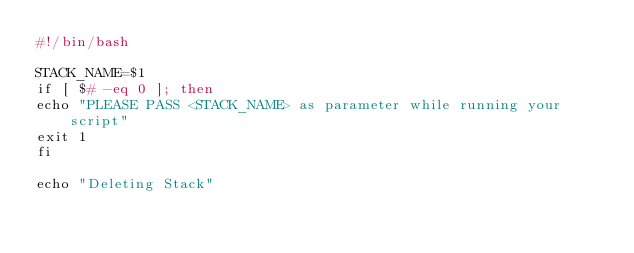Convert code to text. <code><loc_0><loc_0><loc_500><loc_500><_Bash_>#!/bin/bash

STACK_NAME=$1
if [ $# -eq 0 ]; then
echo "PLEASE PASS <STACK_NAME> as parameter while running your script"
exit 1
fi

echo "Deleting Stack"
</code> 